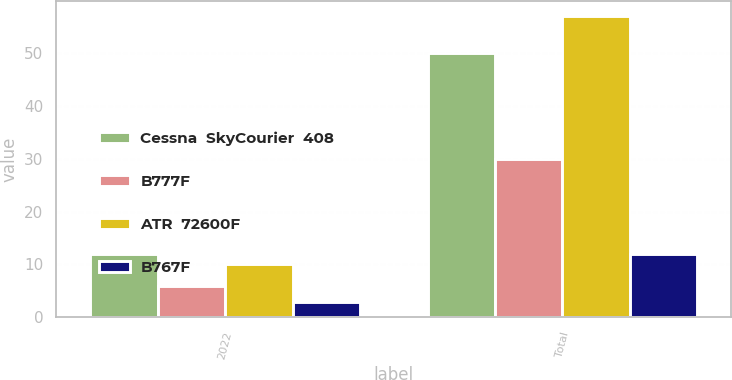<chart> <loc_0><loc_0><loc_500><loc_500><stacked_bar_chart><ecel><fcel>2022<fcel>Total<nl><fcel>Cessna  SkyCourier  408<fcel>12<fcel>50<nl><fcel>B777F<fcel>6<fcel>30<nl><fcel>ATR  72600F<fcel>10<fcel>57<nl><fcel>B767F<fcel>3<fcel>12<nl></chart> 